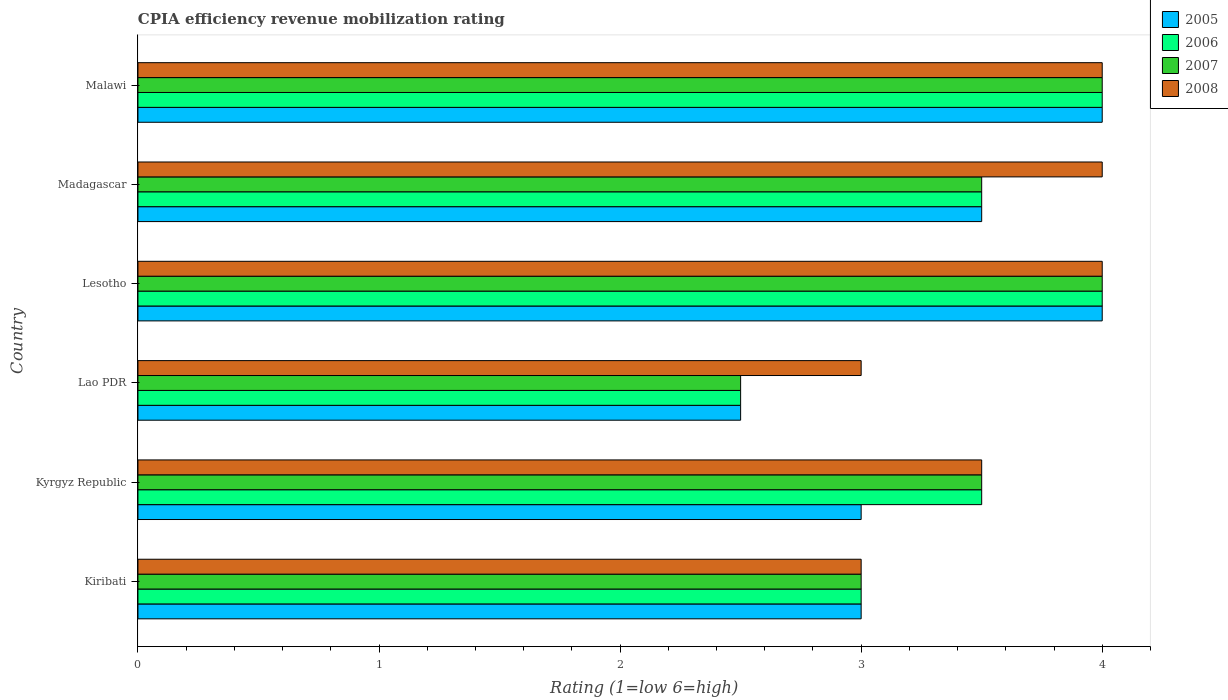How many groups of bars are there?
Make the answer very short. 6. Are the number of bars per tick equal to the number of legend labels?
Give a very brief answer. Yes. What is the label of the 1st group of bars from the top?
Make the answer very short. Malawi. In how many cases, is the number of bars for a given country not equal to the number of legend labels?
Offer a terse response. 0. What is the CPIA rating in 2006 in Lao PDR?
Offer a terse response. 2.5. Across all countries, what is the maximum CPIA rating in 2005?
Your answer should be very brief. 4. In which country was the CPIA rating in 2007 maximum?
Offer a terse response. Lesotho. In which country was the CPIA rating in 2006 minimum?
Provide a succinct answer. Lao PDR. What is the total CPIA rating in 2005 in the graph?
Offer a very short reply. 20. What is the difference between the CPIA rating in 2006 in Kiribati and that in Madagascar?
Your answer should be compact. -0.5. What is the difference between the CPIA rating in 2006 in Lao PDR and the CPIA rating in 2005 in Madagascar?
Offer a very short reply. -1. What is the average CPIA rating in 2005 per country?
Provide a short and direct response. 3.33. What is the difference between the CPIA rating in 2005 and CPIA rating in 2007 in Lesotho?
Ensure brevity in your answer.  0. In how many countries, is the CPIA rating in 2008 greater than 0.6000000000000001 ?
Offer a very short reply. 6. What is the ratio of the CPIA rating in 2007 in Kiribati to that in Madagascar?
Make the answer very short. 0.86. Is the difference between the CPIA rating in 2005 in Lao PDR and Lesotho greater than the difference between the CPIA rating in 2007 in Lao PDR and Lesotho?
Keep it short and to the point. No. What is the difference between the highest and the second highest CPIA rating in 2005?
Make the answer very short. 0. What is the difference between the highest and the lowest CPIA rating in 2007?
Offer a very short reply. 1.5. What does the 1st bar from the top in Kyrgyz Republic represents?
Give a very brief answer. 2008. What does the 4th bar from the bottom in Malawi represents?
Your response must be concise. 2008. How many bars are there?
Provide a succinct answer. 24. What is the difference between two consecutive major ticks on the X-axis?
Offer a terse response. 1. Are the values on the major ticks of X-axis written in scientific E-notation?
Your response must be concise. No. Does the graph contain any zero values?
Make the answer very short. No. How many legend labels are there?
Give a very brief answer. 4. What is the title of the graph?
Offer a terse response. CPIA efficiency revenue mobilization rating. What is the label or title of the X-axis?
Provide a succinct answer. Rating (1=low 6=high). What is the Rating (1=low 6=high) in 2005 in Kiribati?
Make the answer very short. 3. What is the Rating (1=low 6=high) in 2007 in Kiribati?
Your response must be concise. 3. What is the Rating (1=low 6=high) of 2008 in Kiribati?
Ensure brevity in your answer.  3. What is the Rating (1=low 6=high) in 2005 in Lao PDR?
Offer a very short reply. 2.5. What is the Rating (1=low 6=high) of 2006 in Lao PDR?
Your answer should be compact. 2.5. What is the Rating (1=low 6=high) in 2008 in Lesotho?
Ensure brevity in your answer.  4. What is the Rating (1=low 6=high) in 2008 in Madagascar?
Your answer should be very brief. 4. What is the Rating (1=low 6=high) of 2005 in Malawi?
Ensure brevity in your answer.  4. Across all countries, what is the maximum Rating (1=low 6=high) in 2005?
Offer a very short reply. 4. Across all countries, what is the maximum Rating (1=low 6=high) of 2008?
Keep it short and to the point. 4. Across all countries, what is the minimum Rating (1=low 6=high) of 2006?
Offer a very short reply. 2.5. What is the total Rating (1=low 6=high) of 2005 in the graph?
Offer a very short reply. 20. What is the total Rating (1=low 6=high) of 2006 in the graph?
Your answer should be very brief. 20.5. What is the total Rating (1=low 6=high) of 2008 in the graph?
Your answer should be compact. 21.5. What is the difference between the Rating (1=low 6=high) in 2005 in Kiribati and that in Kyrgyz Republic?
Your answer should be very brief. 0. What is the difference between the Rating (1=low 6=high) in 2006 in Kiribati and that in Kyrgyz Republic?
Ensure brevity in your answer.  -0.5. What is the difference between the Rating (1=low 6=high) in 2008 in Kiribati and that in Lao PDR?
Your answer should be very brief. 0. What is the difference between the Rating (1=low 6=high) in 2005 in Kiribati and that in Lesotho?
Provide a succinct answer. -1. What is the difference between the Rating (1=low 6=high) in 2006 in Kiribati and that in Lesotho?
Ensure brevity in your answer.  -1. What is the difference between the Rating (1=low 6=high) of 2008 in Kiribati and that in Lesotho?
Your response must be concise. -1. What is the difference between the Rating (1=low 6=high) of 2008 in Kiribati and that in Madagascar?
Offer a terse response. -1. What is the difference between the Rating (1=low 6=high) of 2006 in Kiribati and that in Malawi?
Make the answer very short. -1. What is the difference between the Rating (1=low 6=high) in 2007 in Kiribati and that in Malawi?
Keep it short and to the point. -1. What is the difference between the Rating (1=low 6=high) in 2008 in Kiribati and that in Malawi?
Keep it short and to the point. -1. What is the difference between the Rating (1=low 6=high) of 2005 in Kyrgyz Republic and that in Lao PDR?
Provide a short and direct response. 0.5. What is the difference between the Rating (1=low 6=high) in 2007 in Kyrgyz Republic and that in Lao PDR?
Ensure brevity in your answer.  1. What is the difference between the Rating (1=low 6=high) of 2008 in Kyrgyz Republic and that in Lao PDR?
Make the answer very short. 0.5. What is the difference between the Rating (1=low 6=high) in 2007 in Kyrgyz Republic and that in Lesotho?
Give a very brief answer. -0.5. What is the difference between the Rating (1=low 6=high) of 2008 in Kyrgyz Republic and that in Lesotho?
Provide a short and direct response. -0.5. What is the difference between the Rating (1=low 6=high) in 2006 in Kyrgyz Republic and that in Madagascar?
Your response must be concise. 0. What is the difference between the Rating (1=low 6=high) in 2007 in Kyrgyz Republic and that in Madagascar?
Offer a terse response. 0. What is the difference between the Rating (1=low 6=high) of 2008 in Kyrgyz Republic and that in Madagascar?
Provide a short and direct response. -0.5. What is the difference between the Rating (1=low 6=high) in 2005 in Kyrgyz Republic and that in Malawi?
Ensure brevity in your answer.  -1. What is the difference between the Rating (1=low 6=high) of 2007 in Kyrgyz Republic and that in Malawi?
Make the answer very short. -0.5. What is the difference between the Rating (1=low 6=high) in 2008 in Kyrgyz Republic and that in Malawi?
Make the answer very short. -0.5. What is the difference between the Rating (1=low 6=high) of 2006 in Lao PDR and that in Lesotho?
Offer a terse response. -1.5. What is the difference between the Rating (1=low 6=high) of 2008 in Lao PDR and that in Lesotho?
Provide a succinct answer. -1. What is the difference between the Rating (1=low 6=high) of 2005 in Lao PDR and that in Malawi?
Your response must be concise. -1.5. What is the difference between the Rating (1=low 6=high) in 2006 in Lao PDR and that in Malawi?
Provide a succinct answer. -1.5. What is the difference between the Rating (1=low 6=high) of 2006 in Lesotho and that in Madagascar?
Your response must be concise. 0.5. What is the difference between the Rating (1=low 6=high) of 2005 in Lesotho and that in Malawi?
Give a very brief answer. 0. What is the difference between the Rating (1=low 6=high) in 2006 in Lesotho and that in Malawi?
Provide a short and direct response. 0. What is the difference between the Rating (1=low 6=high) of 2007 in Lesotho and that in Malawi?
Offer a terse response. 0. What is the difference between the Rating (1=low 6=high) in 2007 in Madagascar and that in Malawi?
Offer a terse response. -0.5. What is the difference between the Rating (1=low 6=high) in 2005 in Kiribati and the Rating (1=low 6=high) in 2006 in Lao PDR?
Give a very brief answer. 0.5. What is the difference between the Rating (1=low 6=high) of 2005 in Kiribati and the Rating (1=low 6=high) of 2007 in Lao PDR?
Make the answer very short. 0.5. What is the difference between the Rating (1=low 6=high) of 2006 in Kiribati and the Rating (1=low 6=high) of 2007 in Lao PDR?
Your answer should be compact. 0.5. What is the difference between the Rating (1=low 6=high) in 2006 in Kiribati and the Rating (1=low 6=high) in 2008 in Lao PDR?
Your answer should be very brief. 0. What is the difference between the Rating (1=low 6=high) in 2007 in Kiribati and the Rating (1=low 6=high) in 2008 in Lao PDR?
Provide a succinct answer. 0. What is the difference between the Rating (1=low 6=high) in 2005 in Kiribati and the Rating (1=low 6=high) in 2007 in Lesotho?
Give a very brief answer. -1. What is the difference between the Rating (1=low 6=high) in 2005 in Kiribati and the Rating (1=low 6=high) in 2008 in Lesotho?
Your answer should be compact. -1. What is the difference between the Rating (1=low 6=high) of 2006 in Kiribati and the Rating (1=low 6=high) of 2007 in Lesotho?
Make the answer very short. -1. What is the difference between the Rating (1=low 6=high) in 2006 in Kiribati and the Rating (1=low 6=high) in 2008 in Lesotho?
Provide a succinct answer. -1. What is the difference between the Rating (1=low 6=high) in 2007 in Kiribati and the Rating (1=low 6=high) in 2008 in Lesotho?
Your answer should be very brief. -1. What is the difference between the Rating (1=low 6=high) in 2005 in Kiribati and the Rating (1=low 6=high) in 2006 in Madagascar?
Your answer should be compact. -0.5. What is the difference between the Rating (1=low 6=high) of 2005 in Kiribati and the Rating (1=low 6=high) of 2008 in Madagascar?
Your answer should be very brief. -1. What is the difference between the Rating (1=low 6=high) in 2006 in Kiribati and the Rating (1=low 6=high) in 2007 in Madagascar?
Give a very brief answer. -0.5. What is the difference between the Rating (1=low 6=high) of 2006 in Kiribati and the Rating (1=low 6=high) of 2008 in Madagascar?
Make the answer very short. -1. What is the difference between the Rating (1=low 6=high) in 2005 in Kiribati and the Rating (1=low 6=high) in 2006 in Malawi?
Ensure brevity in your answer.  -1. What is the difference between the Rating (1=low 6=high) in 2005 in Kiribati and the Rating (1=low 6=high) in 2007 in Malawi?
Your answer should be compact. -1. What is the difference between the Rating (1=low 6=high) of 2006 in Kiribati and the Rating (1=low 6=high) of 2007 in Malawi?
Keep it short and to the point. -1. What is the difference between the Rating (1=low 6=high) of 2006 in Kiribati and the Rating (1=low 6=high) of 2008 in Malawi?
Keep it short and to the point. -1. What is the difference between the Rating (1=low 6=high) in 2005 in Kyrgyz Republic and the Rating (1=low 6=high) in 2007 in Lao PDR?
Offer a terse response. 0.5. What is the difference between the Rating (1=low 6=high) of 2005 in Kyrgyz Republic and the Rating (1=low 6=high) of 2008 in Lao PDR?
Provide a short and direct response. 0. What is the difference between the Rating (1=low 6=high) of 2005 in Kyrgyz Republic and the Rating (1=low 6=high) of 2007 in Lesotho?
Your response must be concise. -1. What is the difference between the Rating (1=low 6=high) of 2006 in Kyrgyz Republic and the Rating (1=low 6=high) of 2008 in Lesotho?
Your answer should be very brief. -0.5. What is the difference between the Rating (1=low 6=high) of 2007 in Kyrgyz Republic and the Rating (1=low 6=high) of 2008 in Lesotho?
Keep it short and to the point. -0.5. What is the difference between the Rating (1=low 6=high) in 2005 in Kyrgyz Republic and the Rating (1=low 6=high) in 2006 in Madagascar?
Keep it short and to the point. -0.5. What is the difference between the Rating (1=low 6=high) in 2005 in Kyrgyz Republic and the Rating (1=low 6=high) in 2007 in Madagascar?
Make the answer very short. -0.5. What is the difference between the Rating (1=low 6=high) in 2005 in Kyrgyz Republic and the Rating (1=low 6=high) in 2007 in Malawi?
Provide a succinct answer. -1. What is the difference between the Rating (1=low 6=high) in 2005 in Kyrgyz Republic and the Rating (1=low 6=high) in 2008 in Malawi?
Offer a very short reply. -1. What is the difference between the Rating (1=low 6=high) of 2006 in Kyrgyz Republic and the Rating (1=low 6=high) of 2008 in Malawi?
Make the answer very short. -0.5. What is the difference between the Rating (1=low 6=high) of 2005 in Lao PDR and the Rating (1=low 6=high) of 2006 in Lesotho?
Your answer should be compact. -1.5. What is the difference between the Rating (1=low 6=high) in 2005 in Lao PDR and the Rating (1=low 6=high) in 2007 in Lesotho?
Give a very brief answer. -1.5. What is the difference between the Rating (1=low 6=high) of 2005 in Lao PDR and the Rating (1=low 6=high) of 2008 in Lesotho?
Your answer should be compact. -1.5. What is the difference between the Rating (1=low 6=high) of 2006 in Lao PDR and the Rating (1=low 6=high) of 2007 in Lesotho?
Keep it short and to the point. -1.5. What is the difference between the Rating (1=low 6=high) of 2007 in Lao PDR and the Rating (1=low 6=high) of 2008 in Lesotho?
Your answer should be very brief. -1.5. What is the difference between the Rating (1=low 6=high) in 2006 in Lao PDR and the Rating (1=low 6=high) in 2007 in Madagascar?
Offer a terse response. -1. What is the difference between the Rating (1=low 6=high) in 2006 in Lao PDR and the Rating (1=low 6=high) in 2008 in Madagascar?
Make the answer very short. -1.5. What is the difference between the Rating (1=low 6=high) of 2007 in Lao PDR and the Rating (1=low 6=high) of 2008 in Madagascar?
Provide a succinct answer. -1.5. What is the difference between the Rating (1=low 6=high) in 2005 in Lao PDR and the Rating (1=low 6=high) in 2006 in Malawi?
Your response must be concise. -1.5. What is the difference between the Rating (1=low 6=high) in 2005 in Lao PDR and the Rating (1=low 6=high) in 2007 in Malawi?
Offer a very short reply. -1.5. What is the difference between the Rating (1=low 6=high) in 2005 in Lao PDR and the Rating (1=low 6=high) in 2008 in Malawi?
Provide a succinct answer. -1.5. What is the difference between the Rating (1=low 6=high) of 2007 in Lao PDR and the Rating (1=low 6=high) of 2008 in Malawi?
Your answer should be compact. -1.5. What is the difference between the Rating (1=low 6=high) in 2005 in Lesotho and the Rating (1=low 6=high) in 2007 in Madagascar?
Provide a succinct answer. 0.5. What is the difference between the Rating (1=low 6=high) of 2006 in Lesotho and the Rating (1=low 6=high) of 2007 in Madagascar?
Offer a terse response. 0.5. What is the difference between the Rating (1=low 6=high) of 2006 in Lesotho and the Rating (1=low 6=high) of 2008 in Madagascar?
Ensure brevity in your answer.  0. What is the difference between the Rating (1=low 6=high) of 2005 in Lesotho and the Rating (1=low 6=high) of 2007 in Malawi?
Your response must be concise. 0. What is the difference between the Rating (1=low 6=high) of 2005 in Lesotho and the Rating (1=low 6=high) of 2008 in Malawi?
Ensure brevity in your answer.  0. What is the difference between the Rating (1=low 6=high) of 2006 in Lesotho and the Rating (1=low 6=high) of 2007 in Malawi?
Offer a very short reply. 0. What is the difference between the Rating (1=low 6=high) in 2007 in Lesotho and the Rating (1=low 6=high) in 2008 in Malawi?
Give a very brief answer. 0. What is the difference between the Rating (1=low 6=high) in 2005 in Madagascar and the Rating (1=low 6=high) in 2006 in Malawi?
Ensure brevity in your answer.  -0.5. What is the difference between the Rating (1=low 6=high) in 2006 in Madagascar and the Rating (1=low 6=high) in 2007 in Malawi?
Provide a succinct answer. -0.5. What is the difference between the Rating (1=low 6=high) of 2007 in Madagascar and the Rating (1=low 6=high) of 2008 in Malawi?
Offer a terse response. -0.5. What is the average Rating (1=low 6=high) of 2005 per country?
Ensure brevity in your answer.  3.33. What is the average Rating (1=low 6=high) in 2006 per country?
Give a very brief answer. 3.42. What is the average Rating (1=low 6=high) in 2007 per country?
Provide a succinct answer. 3.42. What is the average Rating (1=low 6=high) of 2008 per country?
Ensure brevity in your answer.  3.58. What is the difference between the Rating (1=low 6=high) of 2005 and Rating (1=low 6=high) of 2006 in Kiribati?
Offer a very short reply. 0. What is the difference between the Rating (1=low 6=high) in 2005 and Rating (1=low 6=high) in 2008 in Kiribati?
Your answer should be very brief. 0. What is the difference between the Rating (1=low 6=high) of 2006 and Rating (1=low 6=high) of 2007 in Kiribati?
Make the answer very short. 0. What is the difference between the Rating (1=low 6=high) in 2006 and Rating (1=low 6=high) in 2008 in Kiribati?
Provide a succinct answer. 0. What is the difference between the Rating (1=low 6=high) in 2005 and Rating (1=low 6=high) in 2006 in Lao PDR?
Keep it short and to the point. 0. What is the difference between the Rating (1=low 6=high) in 2006 and Rating (1=low 6=high) in 2007 in Lao PDR?
Give a very brief answer. 0. What is the difference between the Rating (1=low 6=high) of 2005 and Rating (1=low 6=high) of 2006 in Lesotho?
Offer a very short reply. 0. What is the difference between the Rating (1=low 6=high) of 2006 and Rating (1=low 6=high) of 2008 in Lesotho?
Keep it short and to the point. 0. What is the difference between the Rating (1=low 6=high) of 2005 and Rating (1=low 6=high) of 2006 in Madagascar?
Make the answer very short. 0. What is the difference between the Rating (1=low 6=high) in 2005 and Rating (1=low 6=high) in 2008 in Madagascar?
Provide a succinct answer. -0.5. What is the difference between the Rating (1=low 6=high) in 2006 and Rating (1=low 6=high) in 2007 in Madagascar?
Offer a terse response. 0. What is the difference between the Rating (1=low 6=high) in 2007 and Rating (1=low 6=high) in 2008 in Madagascar?
Your response must be concise. -0.5. What is the difference between the Rating (1=low 6=high) in 2005 and Rating (1=low 6=high) in 2006 in Malawi?
Your response must be concise. 0. What is the difference between the Rating (1=low 6=high) of 2005 and Rating (1=low 6=high) of 2008 in Malawi?
Keep it short and to the point. 0. What is the difference between the Rating (1=low 6=high) in 2006 and Rating (1=low 6=high) in 2007 in Malawi?
Your response must be concise. 0. What is the ratio of the Rating (1=low 6=high) of 2005 in Kiribati to that in Kyrgyz Republic?
Offer a terse response. 1. What is the ratio of the Rating (1=low 6=high) of 2007 in Kiribati to that in Kyrgyz Republic?
Your response must be concise. 0.86. What is the ratio of the Rating (1=low 6=high) in 2005 in Kiribati to that in Lao PDR?
Offer a terse response. 1.2. What is the ratio of the Rating (1=low 6=high) of 2006 in Kiribati to that in Lao PDR?
Give a very brief answer. 1.2. What is the ratio of the Rating (1=low 6=high) in 2008 in Kiribati to that in Lao PDR?
Give a very brief answer. 1. What is the ratio of the Rating (1=low 6=high) of 2005 in Kiribati to that in Lesotho?
Provide a short and direct response. 0.75. What is the ratio of the Rating (1=low 6=high) of 2008 in Kiribati to that in Lesotho?
Your answer should be compact. 0.75. What is the ratio of the Rating (1=low 6=high) in 2005 in Kiribati to that in Madagascar?
Provide a succinct answer. 0.86. What is the ratio of the Rating (1=low 6=high) in 2007 in Kiribati to that in Madagascar?
Provide a short and direct response. 0.86. What is the ratio of the Rating (1=low 6=high) of 2008 in Kiribati to that in Madagascar?
Your response must be concise. 0.75. What is the ratio of the Rating (1=low 6=high) of 2005 in Kiribati to that in Malawi?
Make the answer very short. 0.75. What is the ratio of the Rating (1=low 6=high) of 2008 in Kiribati to that in Malawi?
Make the answer very short. 0.75. What is the ratio of the Rating (1=low 6=high) in 2005 in Kyrgyz Republic to that in Lao PDR?
Provide a succinct answer. 1.2. What is the ratio of the Rating (1=low 6=high) in 2007 in Kyrgyz Republic to that in Lao PDR?
Your answer should be very brief. 1.4. What is the ratio of the Rating (1=low 6=high) of 2005 in Kyrgyz Republic to that in Lesotho?
Ensure brevity in your answer.  0.75. What is the ratio of the Rating (1=low 6=high) of 2005 in Kyrgyz Republic to that in Madagascar?
Provide a succinct answer. 0.86. What is the ratio of the Rating (1=low 6=high) in 2007 in Kyrgyz Republic to that in Madagascar?
Your answer should be very brief. 1. What is the ratio of the Rating (1=low 6=high) of 2008 in Kyrgyz Republic to that in Madagascar?
Provide a succinct answer. 0.88. What is the ratio of the Rating (1=low 6=high) in 2005 in Kyrgyz Republic to that in Malawi?
Offer a very short reply. 0.75. What is the ratio of the Rating (1=low 6=high) in 2008 in Kyrgyz Republic to that in Malawi?
Ensure brevity in your answer.  0.88. What is the ratio of the Rating (1=low 6=high) in 2005 in Lao PDR to that in Lesotho?
Offer a terse response. 0.62. What is the ratio of the Rating (1=low 6=high) in 2006 in Lao PDR to that in Lesotho?
Give a very brief answer. 0.62. What is the ratio of the Rating (1=low 6=high) of 2006 in Lao PDR to that in Madagascar?
Provide a succinct answer. 0.71. What is the ratio of the Rating (1=low 6=high) in 2006 in Lao PDR to that in Malawi?
Ensure brevity in your answer.  0.62. What is the ratio of the Rating (1=low 6=high) of 2005 in Lesotho to that in Madagascar?
Make the answer very short. 1.14. What is the ratio of the Rating (1=low 6=high) in 2005 in Lesotho to that in Malawi?
Make the answer very short. 1. What is the ratio of the Rating (1=low 6=high) in 2006 in Madagascar to that in Malawi?
Give a very brief answer. 0.88. What is the ratio of the Rating (1=low 6=high) of 2007 in Madagascar to that in Malawi?
Keep it short and to the point. 0.88. What is the ratio of the Rating (1=low 6=high) of 2008 in Madagascar to that in Malawi?
Your response must be concise. 1. What is the difference between the highest and the second highest Rating (1=low 6=high) of 2006?
Your answer should be very brief. 0. What is the difference between the highest and the second highest Rating (1=low 6=high) of 2007?
Give a very brief answer. 0. What is the difference between the highest and the second highest Rating (1=low 6=high) of 2008?
Offer a very short reply. 0. What is the difference between the highest and the lowest Rating (1=low 6=high) in 2007?
Make the answer very short. 1.5. What is the difference between the highest and the lowest Rating (1=low 6=high) of 2008?
Provide a short and direct response. 1. 